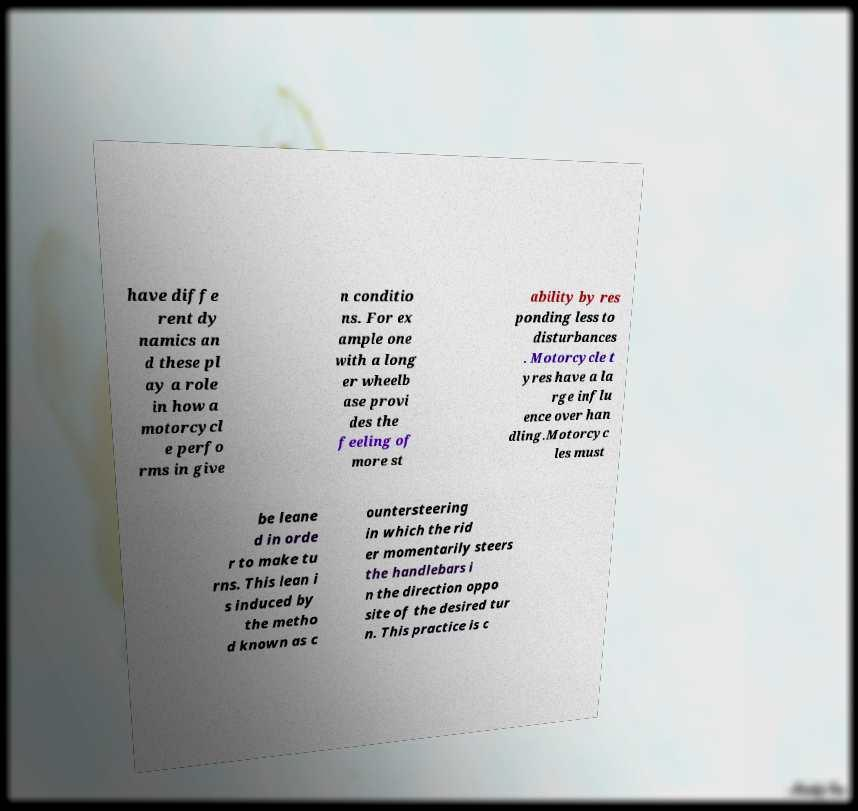Could you assist in decoding the text presented in this image and type it out clearly? have diffe rent dy namics an d these pl ay a role in how a motorcycl e perfo rms in give n conditio ns. For ex ample one with a long er wheelb ase provi des the feeling of more st ability by res ponding less to disturbances . Motorcycle t yres have a la rge influ ence over han dling.Motorcyc les must be leane d in orde r to make tu rns. This lean i s induced by the metho d known as c ountersteering in which the rid er momentarily steers the handlebars i n the direction oppo site of the desired tur n. This practice is c 